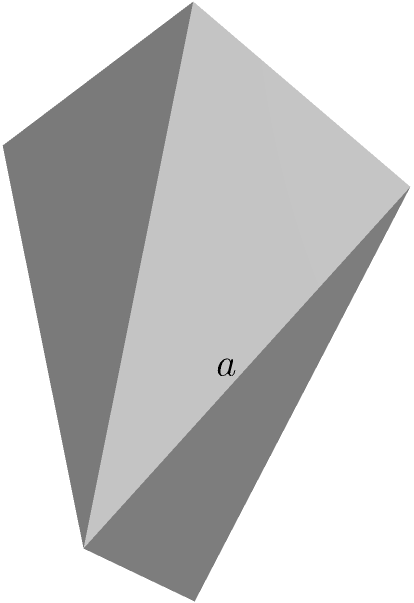In the realm of lexical geometry, consider a regular octahedron with edge length $a$. If we were to "unfold" this three-dimensional shape into a two-dimensional net, what would be the total surface area of this logophile's solid, expressed in terms of $a$? Let's approach this step-by-step, using our love for words to guide us through the mathematical landscape:

1) First, recall that a regular octahedron is composed of 8 congruent equilateral triangles.

2) The area of an equilateral triangle with side length $a$ is given by:
   $$A_{\text{triangle}} = \frac{\sqrt{3}}{4}a^2$$

3) Since there are 8 such triangles, the total surface area will be:
   $$SA_{\text{octahedron}} = 8 \times A_{\text{triangle}}$$

4) Substituting our triangle area formula:
   $$SA_{\text{octahedron}} = 8 \times \frac{\sqrt{3}}{4}a^2$$

5) Simplifying:
   $$SA_{\text{octahedron}} = 2\sqrt{3}a^2$$

This elegant expression, $2\sqrt{3}a^2$, encapsulates the surface area of our octahedron, much like how a well-chosen word can encapsulate a complex idea.
Answer: $2\sqrt{3}a^2$ 